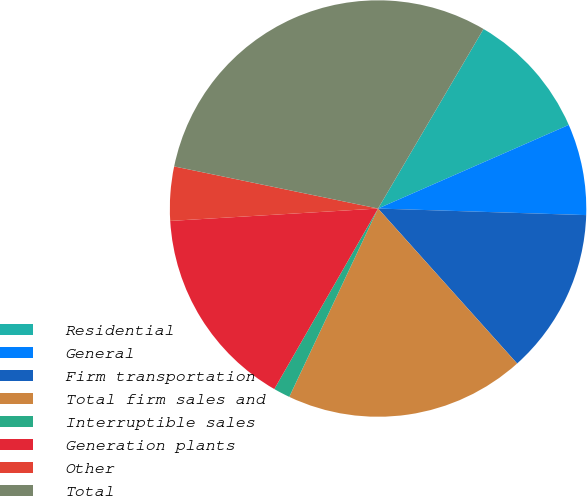<chart> <loc_0><loc_0><loc_500><loc_500><pie_chart><fcel>Residential<fcel>General<fcel>Firm transportation<fcel>Total firm sales and<fcel>Interruptible sales<fcel>Generation plants<fcel>Other<fcel>Total<nl><fcel>9.97%<fcel>7.08%<fcel>12.86%<fcel>18.65%<fcel>1.29%<fcel>15.75%<fcel>4.19%<fcel>30.21%<nl></chart> 